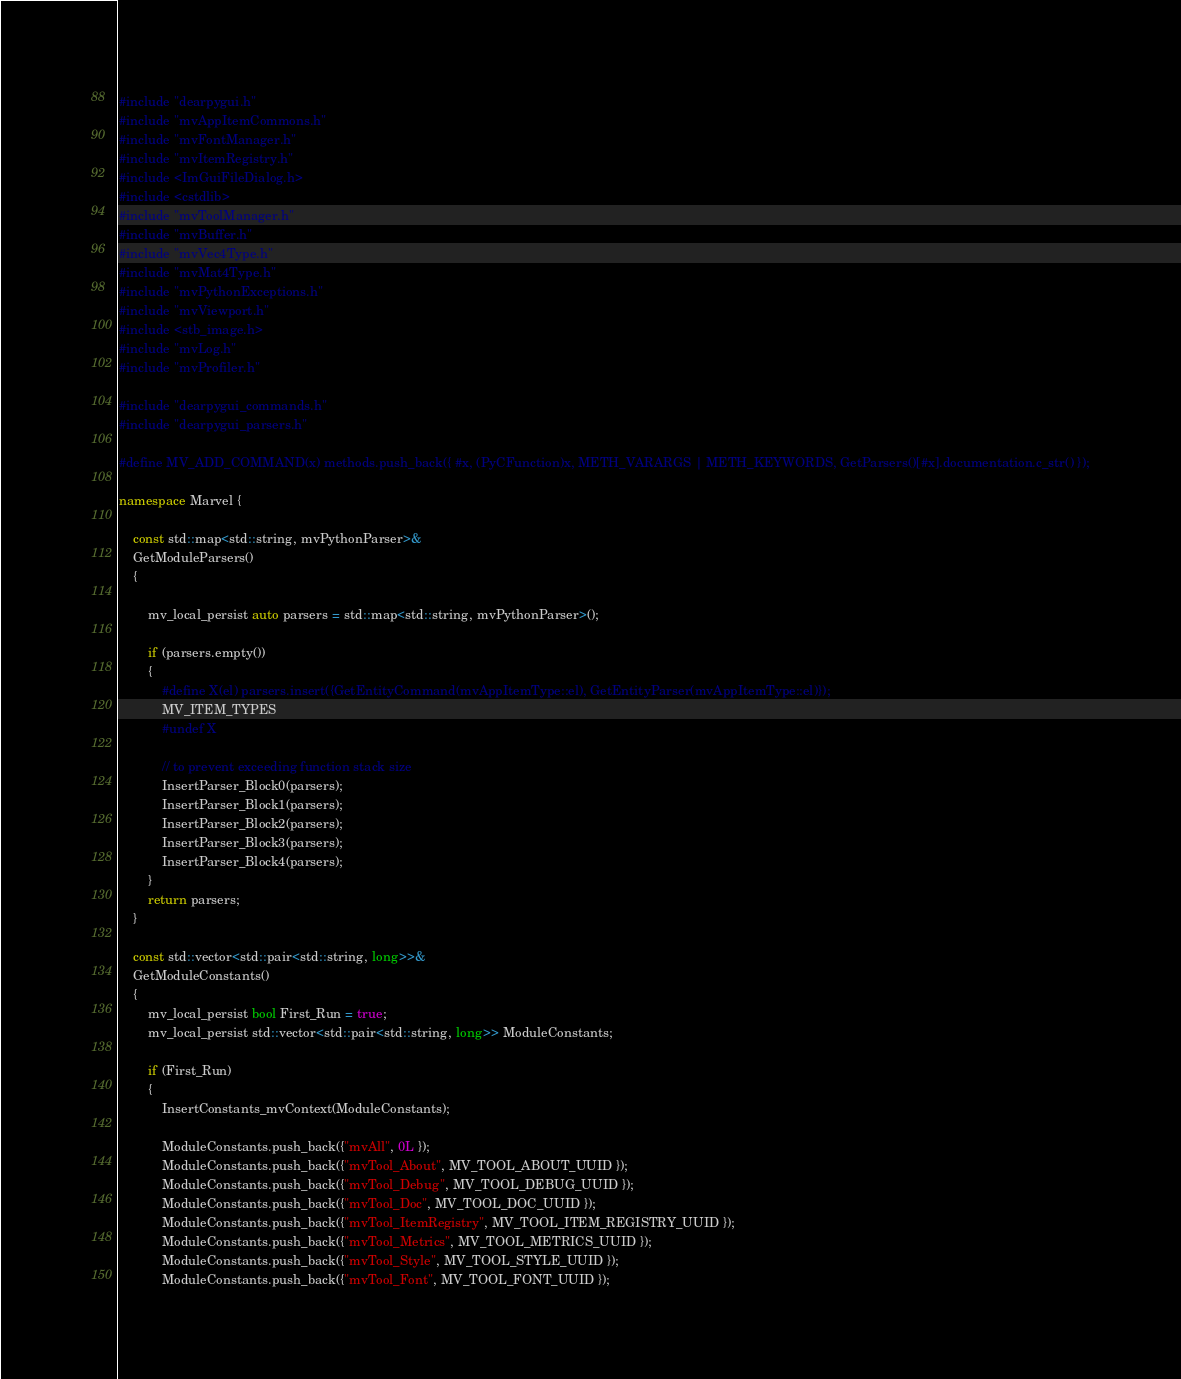<code> <loc_0><loc_0><loc_500><loc_500><_C++_>#include "dearpygui.h"
#include "mvAppItemCommons.h"
#include "mvFontManager.h"
#include "mvItemRegistry.h"
#include <ImGuiFileDialog.h>
#include <cstdlib>
#include "mvToolManager.h"
#include "mvBuffer.h"
#include "mvVec4Type.h"
#include "mvMat4Type.h"
#include "mvPythonExceptions.h"
#include "mvViewport.h"
#include <stb_image.h>
#include "mvLog.h"
#include "mvProfiler.h"

#include "dearpygui_commands.h"
#include "dearpygui_parsers.h"

#define MV_ADD_COMMAND(x) methods.push_back({ #x, (PyCFunction)x, METH_VARARGS | METH_KEYWORDS, GetParsers()[#x].documentation.c_str() });

namespace Marvel {

	const std::map<std::string, mvPythonParser>& 
	GetModuleParsers()
	{

		mv_local_persist auto parsers = std::map<std::string, mvPythonParser>();

		if (parsers.empty())
		{
			#define X(el) parsers.insert({GetEntityCommand(mvAppItemType::el), GetEntityParser(mvAppItemType::el)});
			MV_ITEM_TYPES
			#undef X

			// to prevent exceeding function stack size
			InsertParser_Block0(parsers);
			InsertParser_Block1(parsers);
			InsertParser_Block2(parsers);
			InsertParser_Block3(parsers);
			InsertParser_Block4(parsers);
		}
		return parsers;
	}

	const std::vector<std::pair<std::string, long>>&
	GetModuleConstants()
	{
		mv_local_persist bool First_Run = true;
		mv_local_persist std::vector<std::pair<std::string, long>> ModuleConstants;

		if (First_Run)
		{
			InsertConstants_mvContext(ModuleConstants);

			ModuleConstants.push_back({"mvAll", 0L });
			ModuleConstants.push_back({"mvTool_About", MV_TOOL_ABOUT_UUID });
			ModuleConstants.push_back({"mvTool_Debug", MV_TOOL_DEBUG_UUID });
			ModuleConstants.push_back({"mvTool_Doc", MV_TOOL_DOC_UUID });
			ModuleConstants.push_back({"mvTool_ItemRegistry", MV_TOOL_ITEM_REGISTRY_UUID });
			ModuleConstants.push_back({"mvTool_Metrics", MV_TOOL_METRICS_UUID });
			ModuleConstants.push_back({"mvTool_Style", MV_TOOL_STYLE_UUID });
			ModuleConstants.push_back({"mvTool_Font", MV_TOOL_FONT_UUID });</code> 